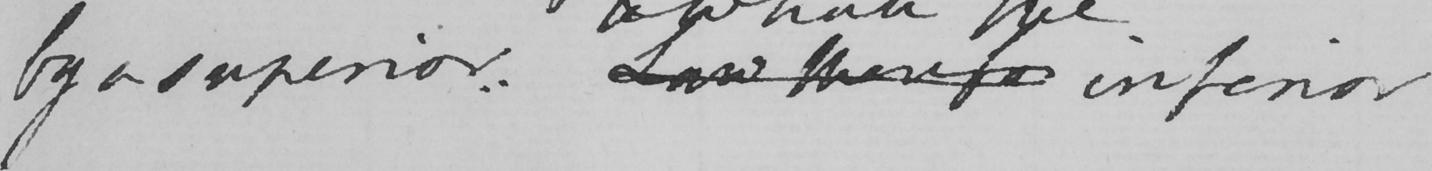Please transcribe the handwritten text in this image. by a superior , Law therefo inferior 